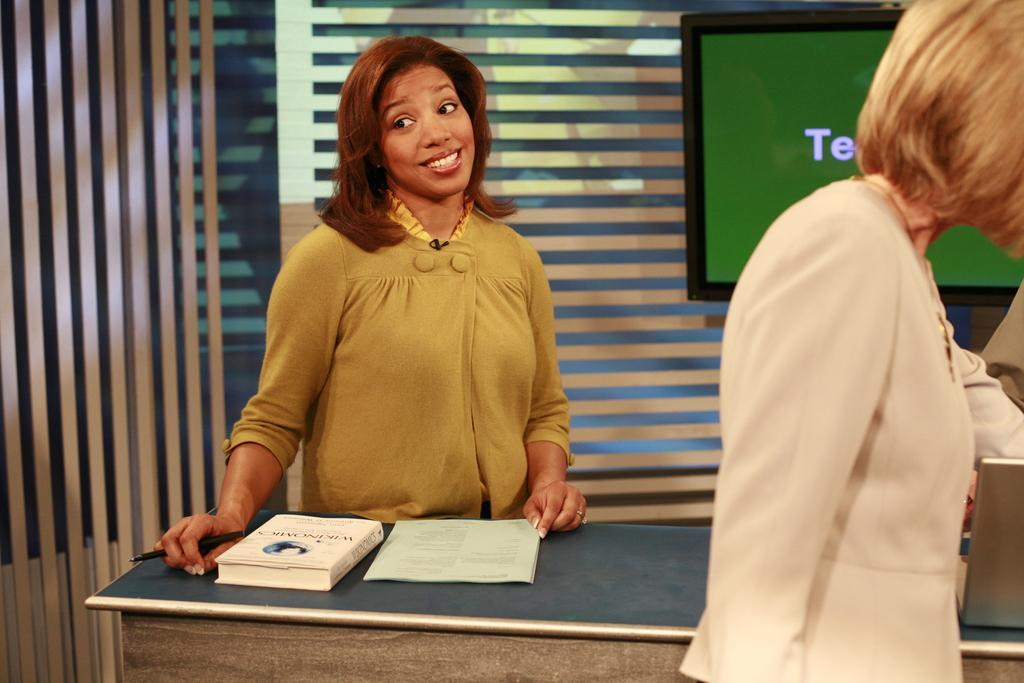Please provide a concise description of this image. A lady in yellow dress is standing and smiling, holding a pen. In front of her there is a table. On the table there is a book and some papers. In the background there is a wall and a television is there. And in the front there is a lady wearing a white dress is walking. 